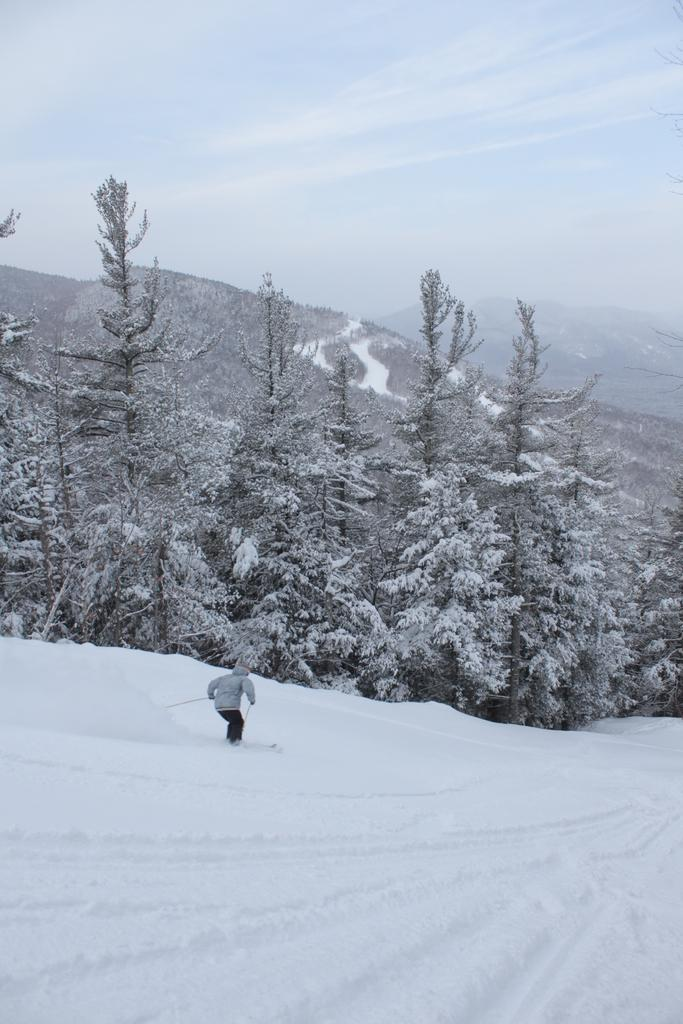What activity is the person in the image engaged in? The person is skiing in the image. On what surface is the person skiing? The person is skiing on snow. What can be seen in the background of the image? There are trees covered with snow and mountains visible in the image. What is visible in the sky in the image? The sky is visible in the image, and clouds are present. Can you tell me where the person's aunt is in the image? There is no mention of an aunt in the image, so it is not possible to determine her location. 